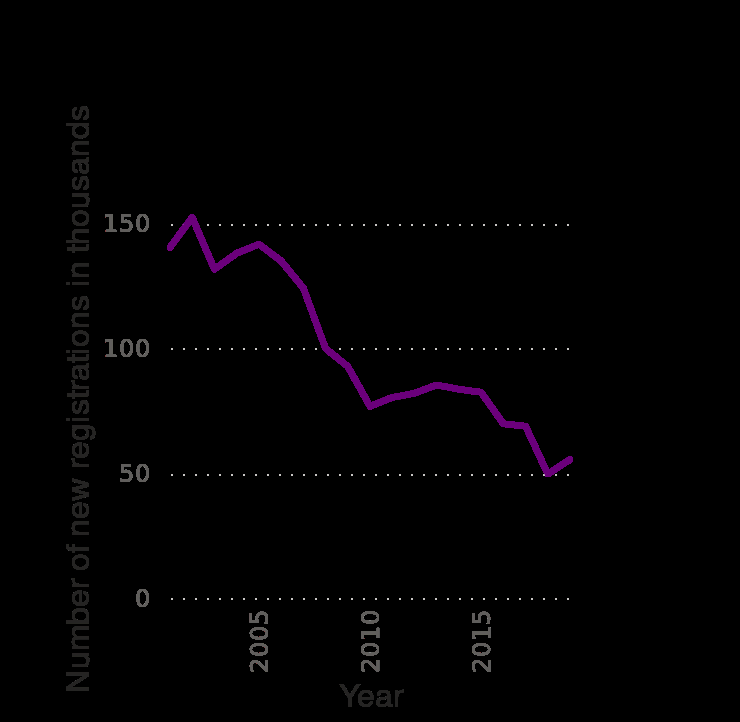<image>
Has the number of new registrations of Ford Focus passenger cars generally increased or decreased over time? To determine whether the number of new registrations has generally increased or decreased over time, the trend of the line chart needs to be analyzed. Unfortunately, the line chart is not available, so the answer cannot be determined. 